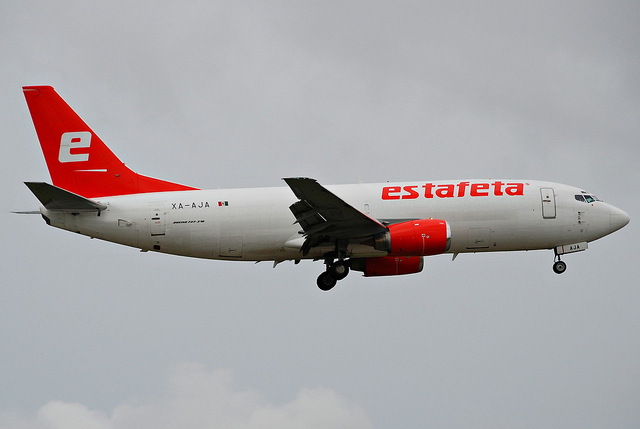Please transcribe the text in this image. estafeta XA-AJA e 